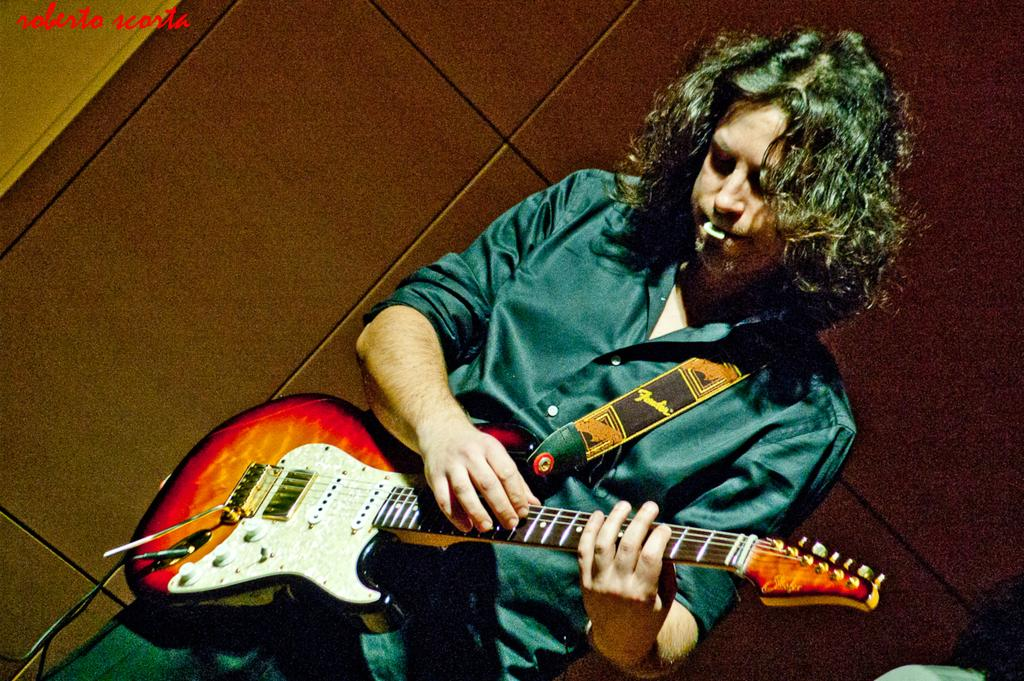What is the main subject of the image? There is a man in the image. Can you describe the man's appearance? The man has short hair. What is the man doing in the image? The man is standing and playing a guitar. Is there anything unusual about the man in the image? Yes, there is a coin in the man's mouth. What type of wine is the scarecrow holding in the image? There is no scarecrow or wine present in the image; it features a man playing a guitar with a coin in his mouth. 